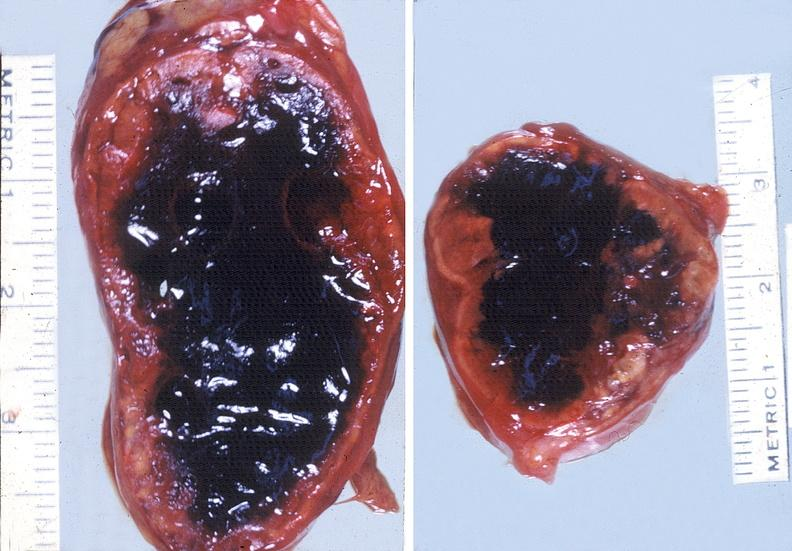does this image show adrenal, hemorrhage?
Answer the question using a single word or phrase. Yes 